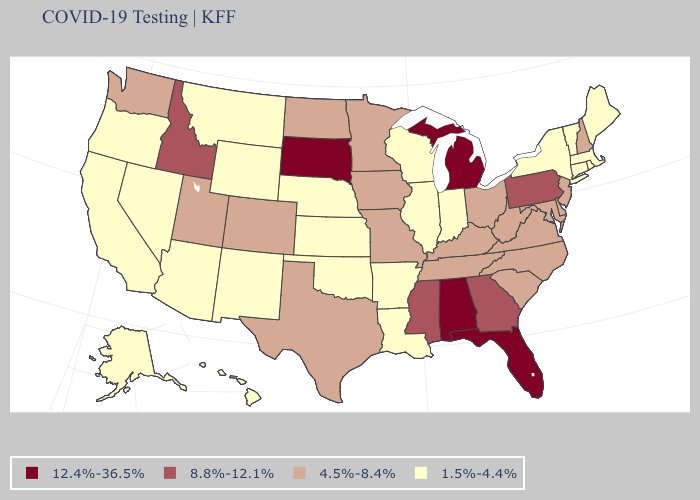Among the states that border Georgia , does Florida have the highest value?
Write a very short answer. Yes. Does Illinois have the lowest value in the USA?
Keep it brief. Yes. How many symbols are there in the legend?
Write a very short answer. 4. What is the lowest value in states that border New York?
Be succinct. 1.5%-4.4%. Which states have the lowest value in the MidWest?
Write a very short answer. Illinois, Indiana, Kansas, Nebraska, Wisconsin. Does the first symbol in the legend represent the smallest category?
Concise answer only. No. Does the first symbol in the legend represent the smallest category?
Be succinct. No. Name the states that have a value in the range 4.5%-8.4%?
Give a very brief answer. Colorado, Delaware, Iowa, Kentucky, Maryland, Minnesota, Missouri, New Hampshire, New Jersey, North Carolina, North Dakota, Ohio, South Carolina, Tennessee, Texas, Utah, Virginia, Washington, West Virginia. What is the highest value in the USA?
Answer briefly. 12.4%-36.5%. What is the highest value in the MidWest ?
Quick response, please. 12.4%-36.5%. Among the states that border Illinois , does Indiana have the lowest value?
Concise answer only. Yes. What is the value of Iowa?
Short answer required. 4.5%-8.4%. What is the lowest value in the MidWest?
Keep it brief. 1.5%-4.4%. Does Pennsylvania have the highest value in the Northeast?
Concise answer only. Yes. What is the value of Illinois?
Answer briefly. 1.5%-4.4%. 